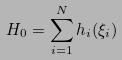Convert formula to latex. <formula><loc_0><loc_0><loc_500><loc_500>H _ { 0 } = \sum _ { i = 1 } ^ { N } h _ { i } ( \xi _ { i } )</formula> 